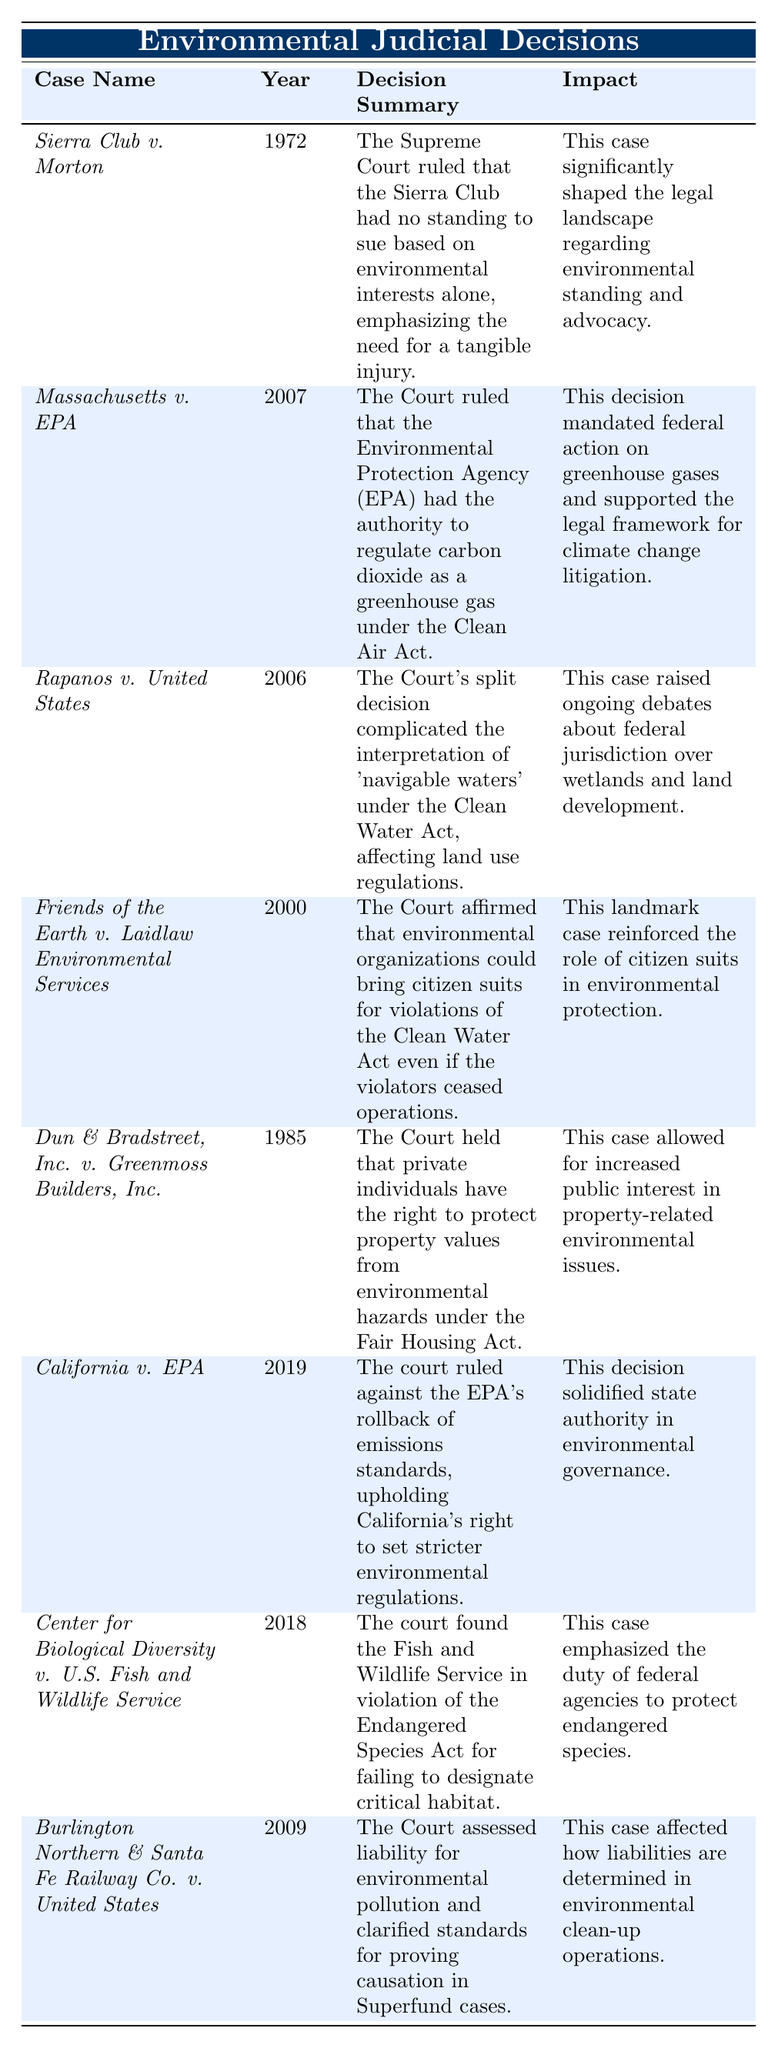What year was "Sierra Club v. Morton" decided? The table lists the year for each judicial decision. For "Sierra Club v. Morton," it is indicated as 1972.
Answer: 1972 Which jurisdiction handled "Friends of the Earth v. Laidlaw Environmental Services"? The jurisdiction of "Friends of the Earth v. Laidlaw Environmental Services" is found in the corresponding column of the table, which specifies that it was handled by the U.S. Supreme Court.
Answer: U.S. Supreme Court What was the impact of "Massachusetts v. EPA"? By examining the table's impact column, it's clear that the impact of "Massachusetts v. EPA" includes mandating federal action on greenhouse gases and supporting the legal framework for climate change litigation.
Answer: Mandated federal action on greenhouse gases How many cases were decided by the U.S. Supreme Court? To find this, count the number of entries in the table under the U.S. Supreme Court jurisdiction, which are Sierra Club v. Morton, Massachusetts v. EPA, Rapanos v. United States, Friends of the Earth v. Laidlaw Environmental Services, Dun & Bradstreet, Inc. v. Greenmoss Builders, Inc., and Burlington Northern & Santa Fe Railway Co. v. United States (totaling 6 cases).
Answer: 6 Which decision was made in 2019? The table indicates that the case decided in 2019 is "California v. EPA," found in the respective year column.
Answer: California v. EPA Did "Burlington Northern & Santa Fe Railway Co. v. United States" address federal agency duties? The description in the "Burlington Northern & Santa Fe Railway Co. v. United States" case focuses on liability and causation standards, not directly on federal agency duties, which means the statement is false.
Answer: No Which case emphasized the need for tangible injury in lawsuits? The "Sierra Club v. Morton" case is noted for its summary that emphasizes the need for tangible injury to establish standing in lawsuits, fulfilling the criteria for the question.
Answer: Sierra Club v. Morton What do the impacts of "California v. EPA" and "Center for Biological Diversity v. U.S. Fish and Wildlife Service" focus on? Both impacts focus on reinforcing authority in environmental governance and the obligation of federal agencies, respectively. "California v. EPA" solidifies state authority, while "Center for Biological Diversity v. U.S. Fish and Wildlife Service" emphasizes the duty of federal agencies to protect endangered species. Thus, the similarity lies in advocating for environmental governance.
Answer: Both emphasize environmental governance What was the general trend in the years of these decisions? By inspecting the years of the judicial decisions, we note they are from 1972 to 2019, displaying an increasing trend where more recent cases relate closely to contemporary environmental issues and advocacy. This indicates a progression in judicial consideration of environmental matters over time.
Answer: Increasing trend in more recent cases Which case indicates a conflict between state and federal authority? According to the table, "California v. EPA" signifies a dispute over state rights in setting environmental standards against federal EPA regulations, reflecting the tension between state and federal authority.
Answer: California v. EPA 